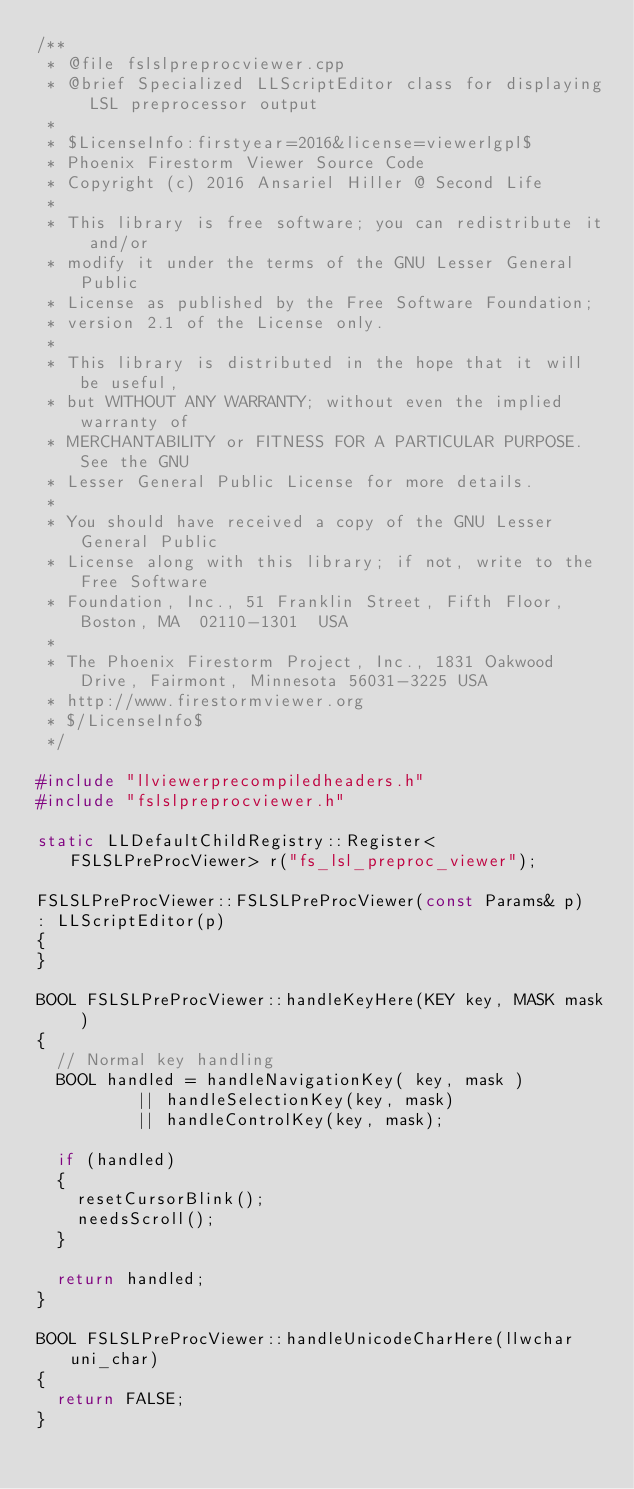Convert code to text. <code><loc_0><loc_0><loc_500><loc_500><_C++_>/** 
 * @file fslslpreprocviewer.cpp
 * @brief Specialized LLScriptEditor class for displaying LSL preprocessor output
 *
 * $LicenseInfo:firstyear=2016&license=viewerlgpl$
 * Phoenix Firestorm Viewer Source Code
 * Copyright (c) 2016 Ansariel Hiller @ Second Life
 * 
 * This library is free software; you can redistribute it and/or
 * modify it under the terms of the GNU Lesser General Public
 * License as published by the Free Software Foundation;
 * version 2.1 of the License only.
 * 
 * This library is distributed in the hope that it will be useful,
 * but WITHOUT ANY WARRANTY; without even the implied warranty of
 * MERCHANTABILITY or FITNESS FOR A PARTICULAR PURPOSE.  See the GNU
 * Lesser General Public License for more details.
 * 
 * You should have received a copy of the GNU Lesser General Public
 * License along with this library; if not, write to the Free Software
 * Foundation, Inc., 51 Franklin Street, Fifth Floor, Boston, MA  02110-1301  USA
 * 
 * The Phoenix Firestorm Project, Inc., 1831 Oakwood Drive, Fairmont, Minnesota 56031-3225 USA
 * http://www.firestormviewer.org
 * $/LicenseInfo$
 */

#include "llviewerprecompiledheaders.h"
#include "fslslpreprocviewer.h"

static LLDefaultChildRegistry::Register<FSLSLPreProcViewer> r("fs_lsl_preproc_viewer");

FSLSLPreProcViewer::FSLSLPreProcViewer(const Params& p)
:	LLScriptEditor(p)
{
}

BOOL FSLSLPreProcViewer::handleKeyHere(KEY key, MASK mask )
{
	// Normal key handling
	BOOL handled = handleNavigationKey( key, mask )
					|| handleSelectionKey(key, mask)
					|| handleControlKey(key, mask);

	if (handled)
	{
		resetCursorBlink();
		needsScroll();
	}

	return handled;
}

BOOL FSLSLPreProcViewer::handleUnicodeCharHere(llwchar uni_char)
{
	return FALSE;
}
</code> 